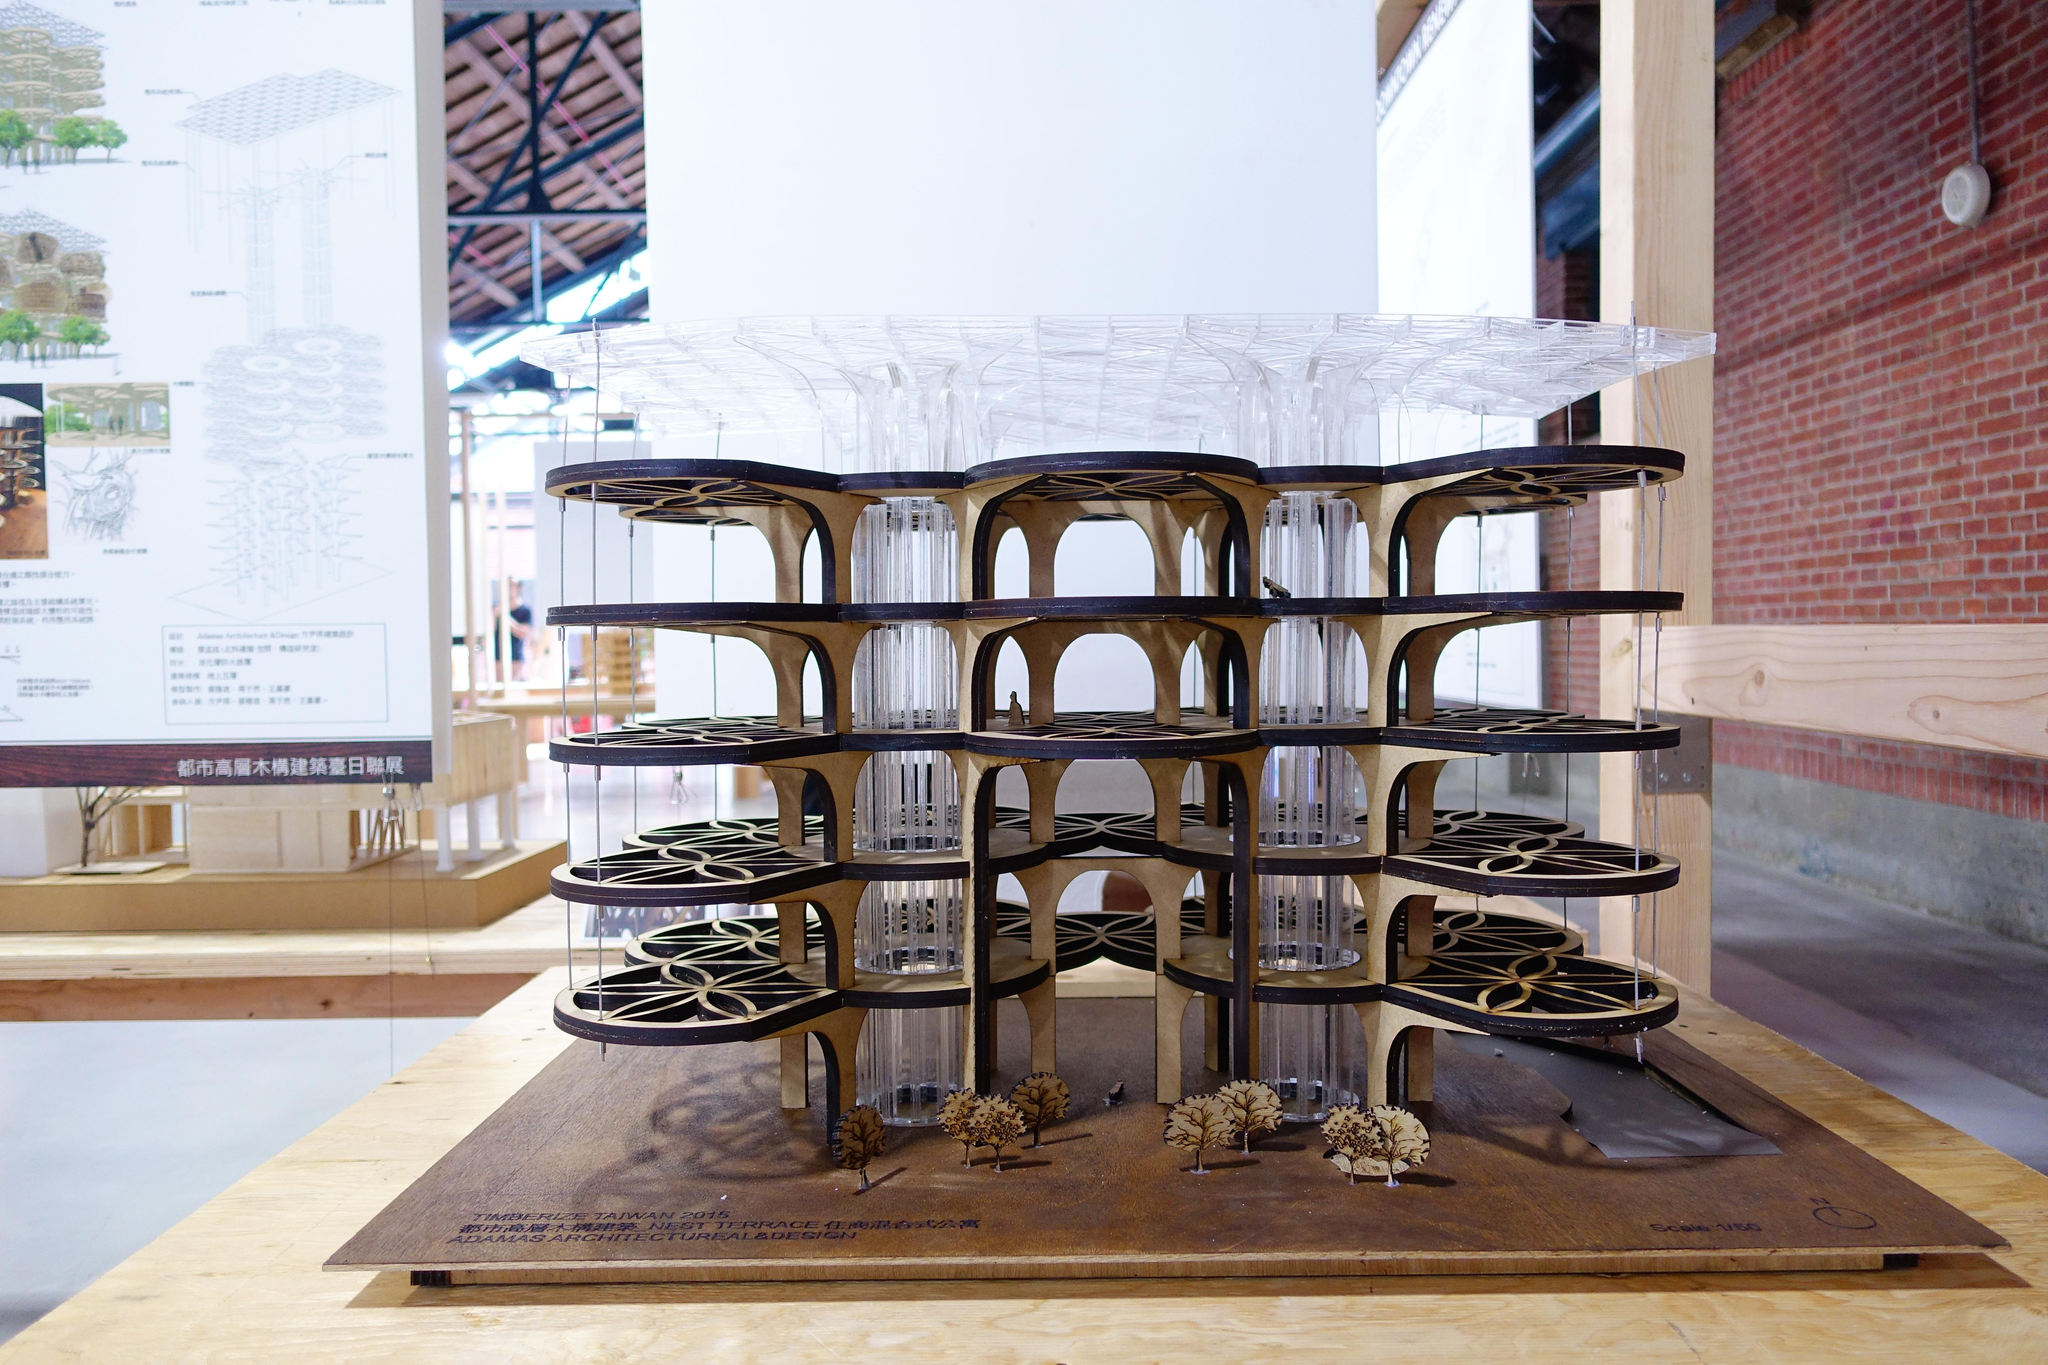What type of structure is visible in the image? There is a building structure in the image. What can be seen on the right side of the image? There is a wall on the right side of the image. What is located on the left side of the image? There is a banner on the left side of the image. What is at the bottom of the image? There is a wooden plank at the bottom of the image. What type of pancake is being served on the desk in the image? There is no desk or pancake present in the image. How many pickles are visible on the wooden plank in the image? There are no pickles visible on the wooden plank in the image. 